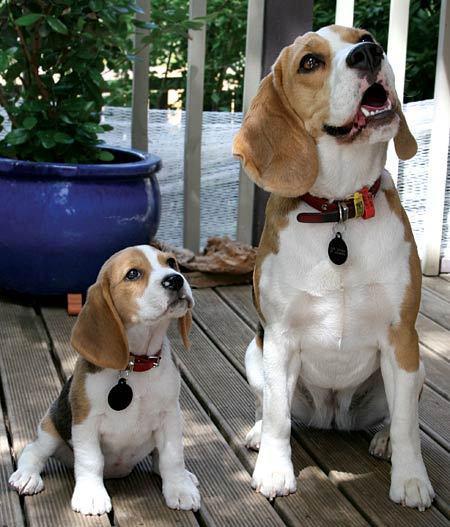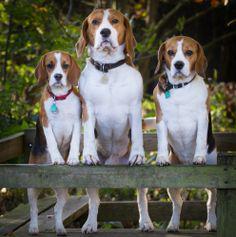The first image is the image on the left, the second image is the image on the right. For the images shown, is this caption "An image shows beagle dogs behind a horizontal wood plank rail." true? Answer yes or no. Yes. 